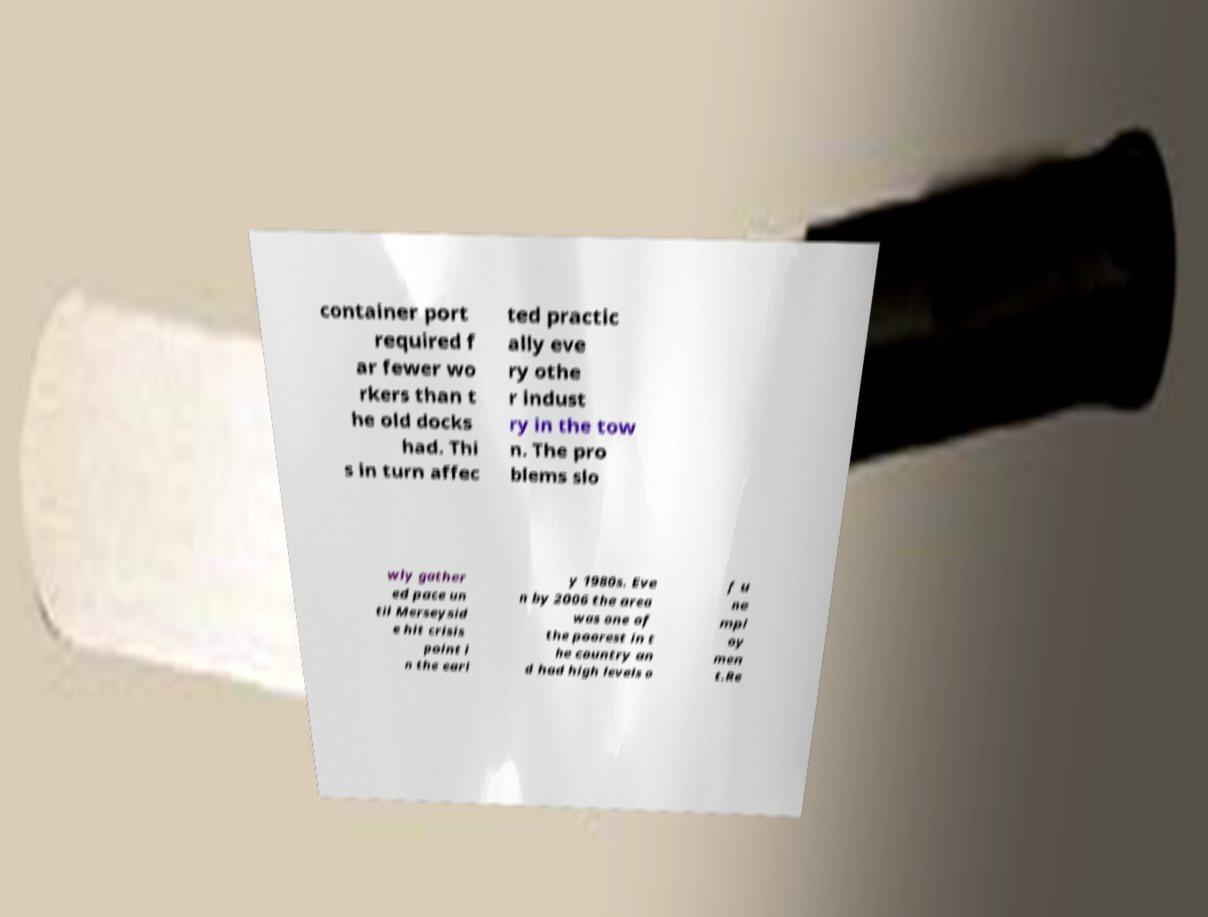Please read and relay the text visible in this image. What does it say? container port required f ar fewer wo rkers than t he old docks had. Thi s in turn affec ted practic ally eve ry othe r indust ry in the tow n. The pro blems slo wly gather ed pace un til Merseysid e hit crisis point i n the earl y 1980s. Eve n by 2006 the area was one of the poorest in t he country an d had high levels o f u ne mpl oy men t.Re 